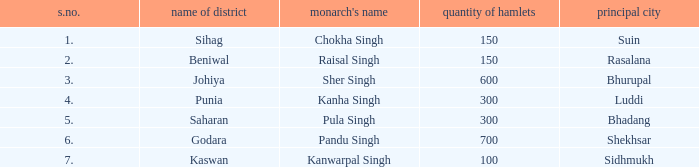What is the average number of villages with a name of janapada of Punia? 300.0. 